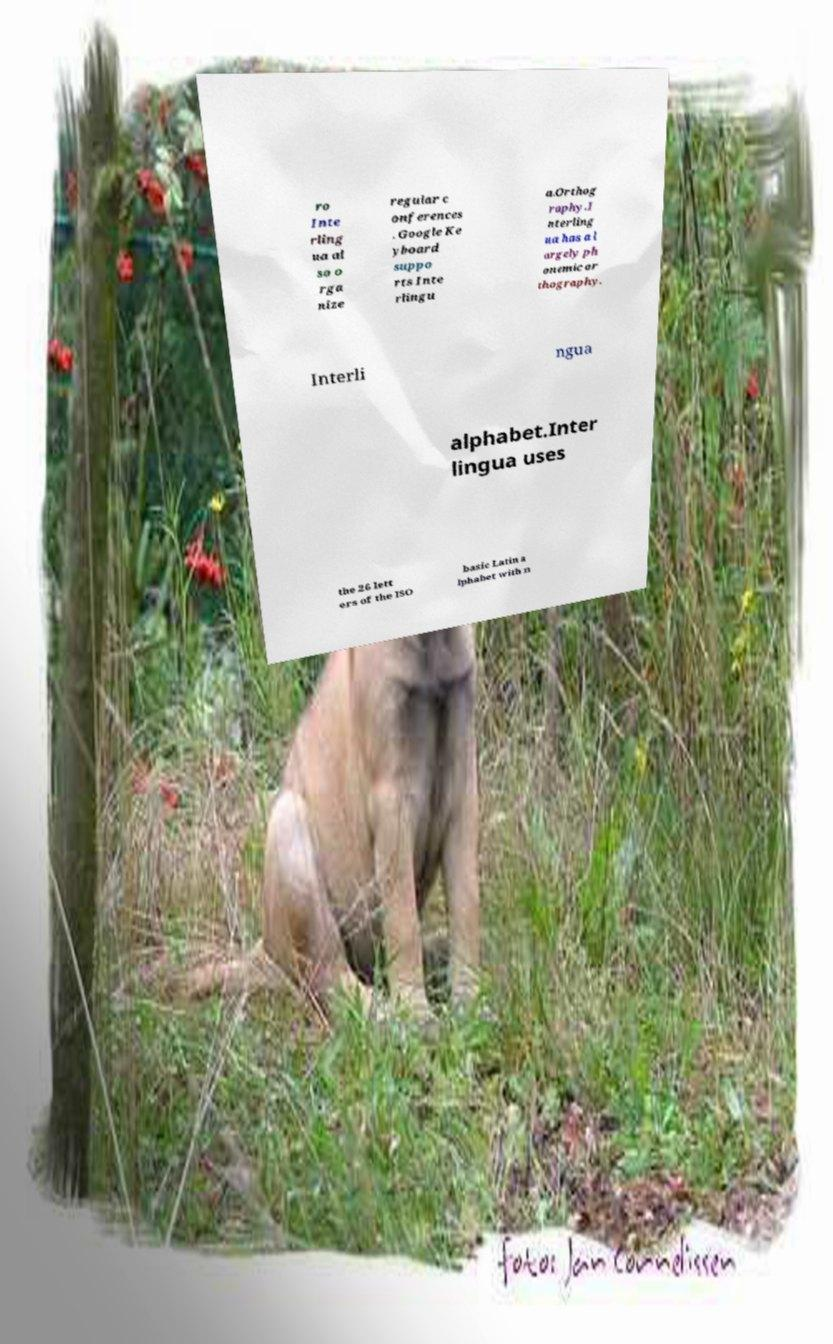Please read and relay the text visible in this image. What does it say? ro Inte rling ua al so o rga nize regular c onferences . Google Ke yboard suppo rts Inte rlingu a.Orthog raphy.I nterling ua has a l argely ph onemic or thography. Interli ngua alphabet.Inter lingua uses the 26 lett ers of the ISO basic Latin a lphabet with n 